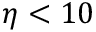<formula> <loc_0><loc_0><loc_500><loc_500>\eta < 1 0</formula> 